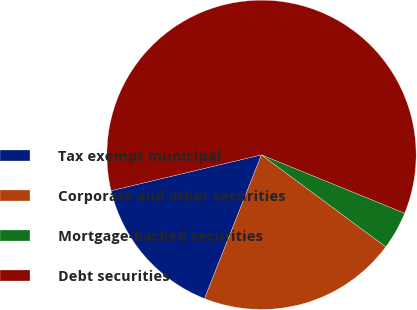Convert chart to OTSL. <chart><loc_0><loc_0><loc_500><loc_500><pie_chart><fcel>Tax exempt municipal<fcel>Corporate and other securities<fcel>Mortgage-backed securities<fcel>Debt securities<nl><fcel>15.27%<fcel>20.86%<fcel>3.98%<fcel>59.88%<nl></chart> 